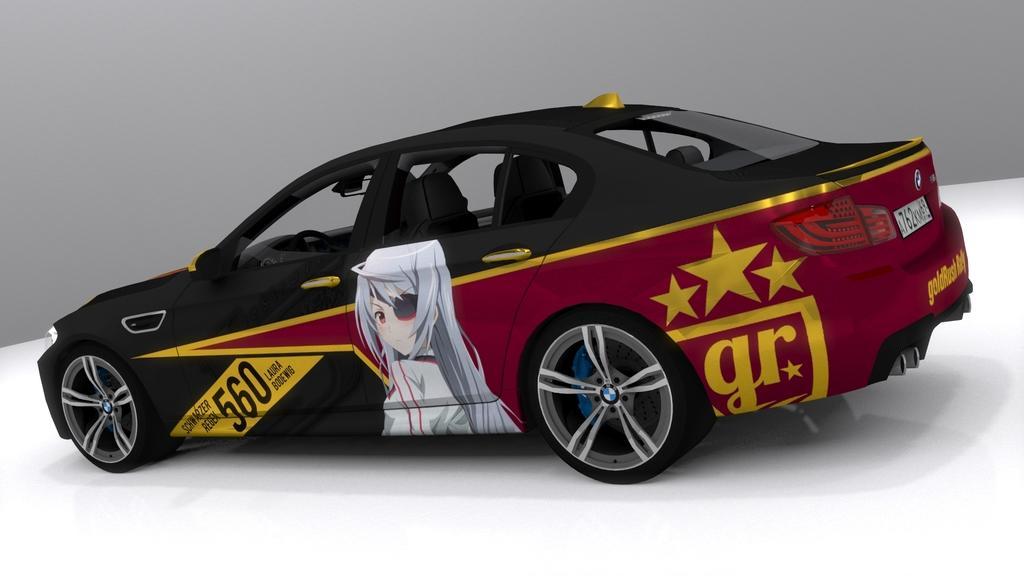Can you describe this image briefly? In this image we can see there is a car. 